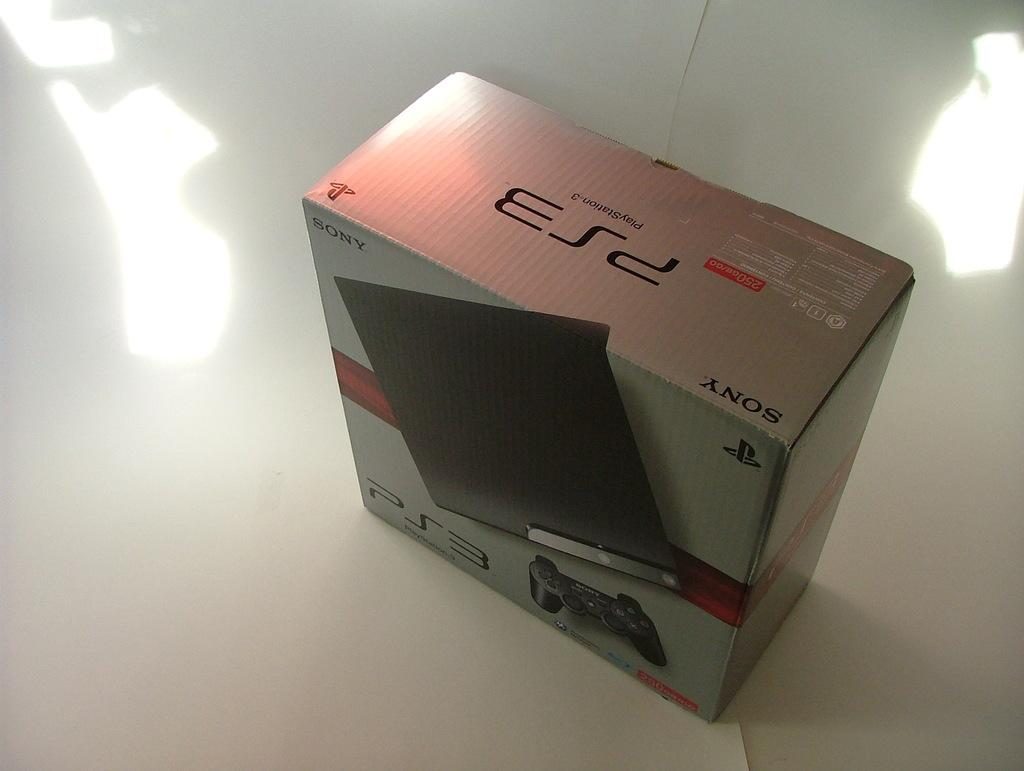<image>
Render a clear and concise summary of the photo. A box that has the image of a PS3 on the front of it. 